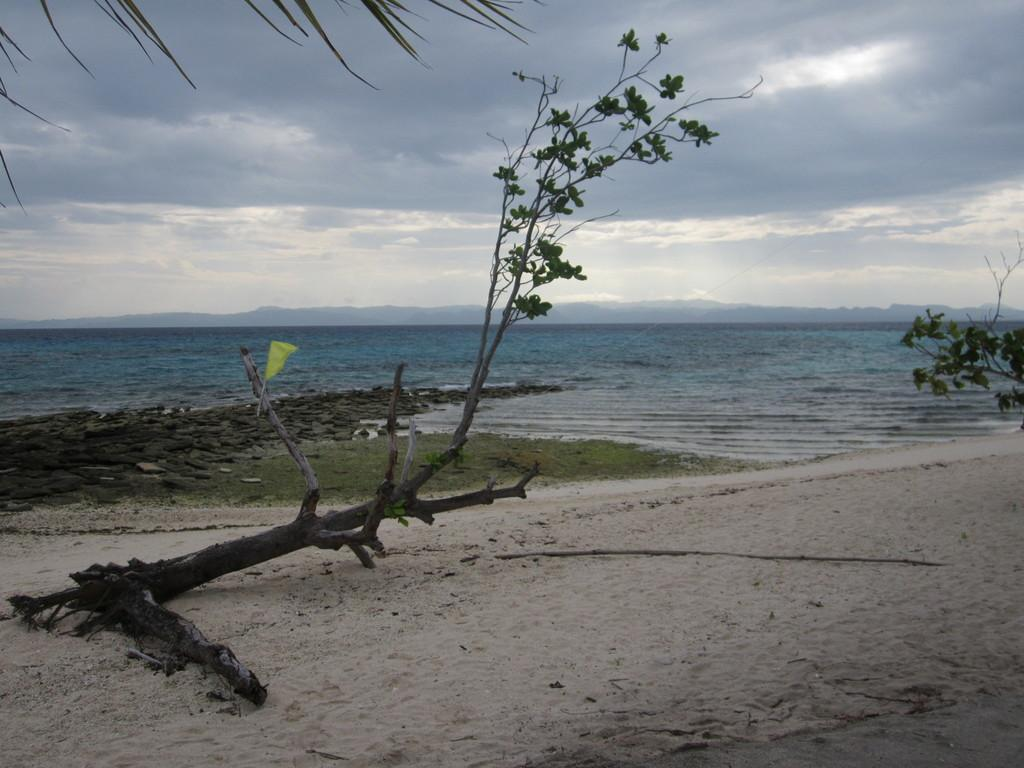What type of natural environment is depicted in the image? The image contains the sea. What type of vegetation is present in front of the sea? There is grass, rocks, and trees visible in front of the sea. What type of terrain is in front of the sea? There is sand in front of the sea. What can be seen in the background of the image? Mountains are visible in the background of the image. What is visible at the top of the image? The sky is visible at the top of the image. What type of industry can be seen operating near the sea in the image? There is no industry present in the image; it depicts a natural environment with the sea, grass, rocks, trees, sand, mountains, and sky. 